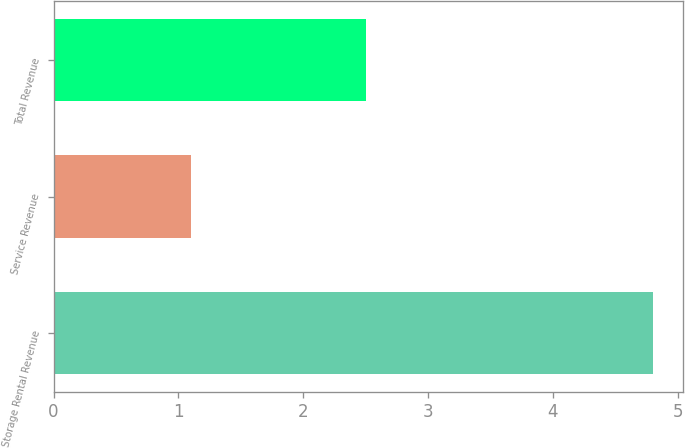Convert chart. <chart><loc_0><loc_0><loc_500><loc_500><bar_chart><fcel>Storage Rental Revenue<fcel>Service Revenue<fcel>Total Revenue<nl><fcel>4.8<fcel>1.1<fcel>2.5<nl></chart> 